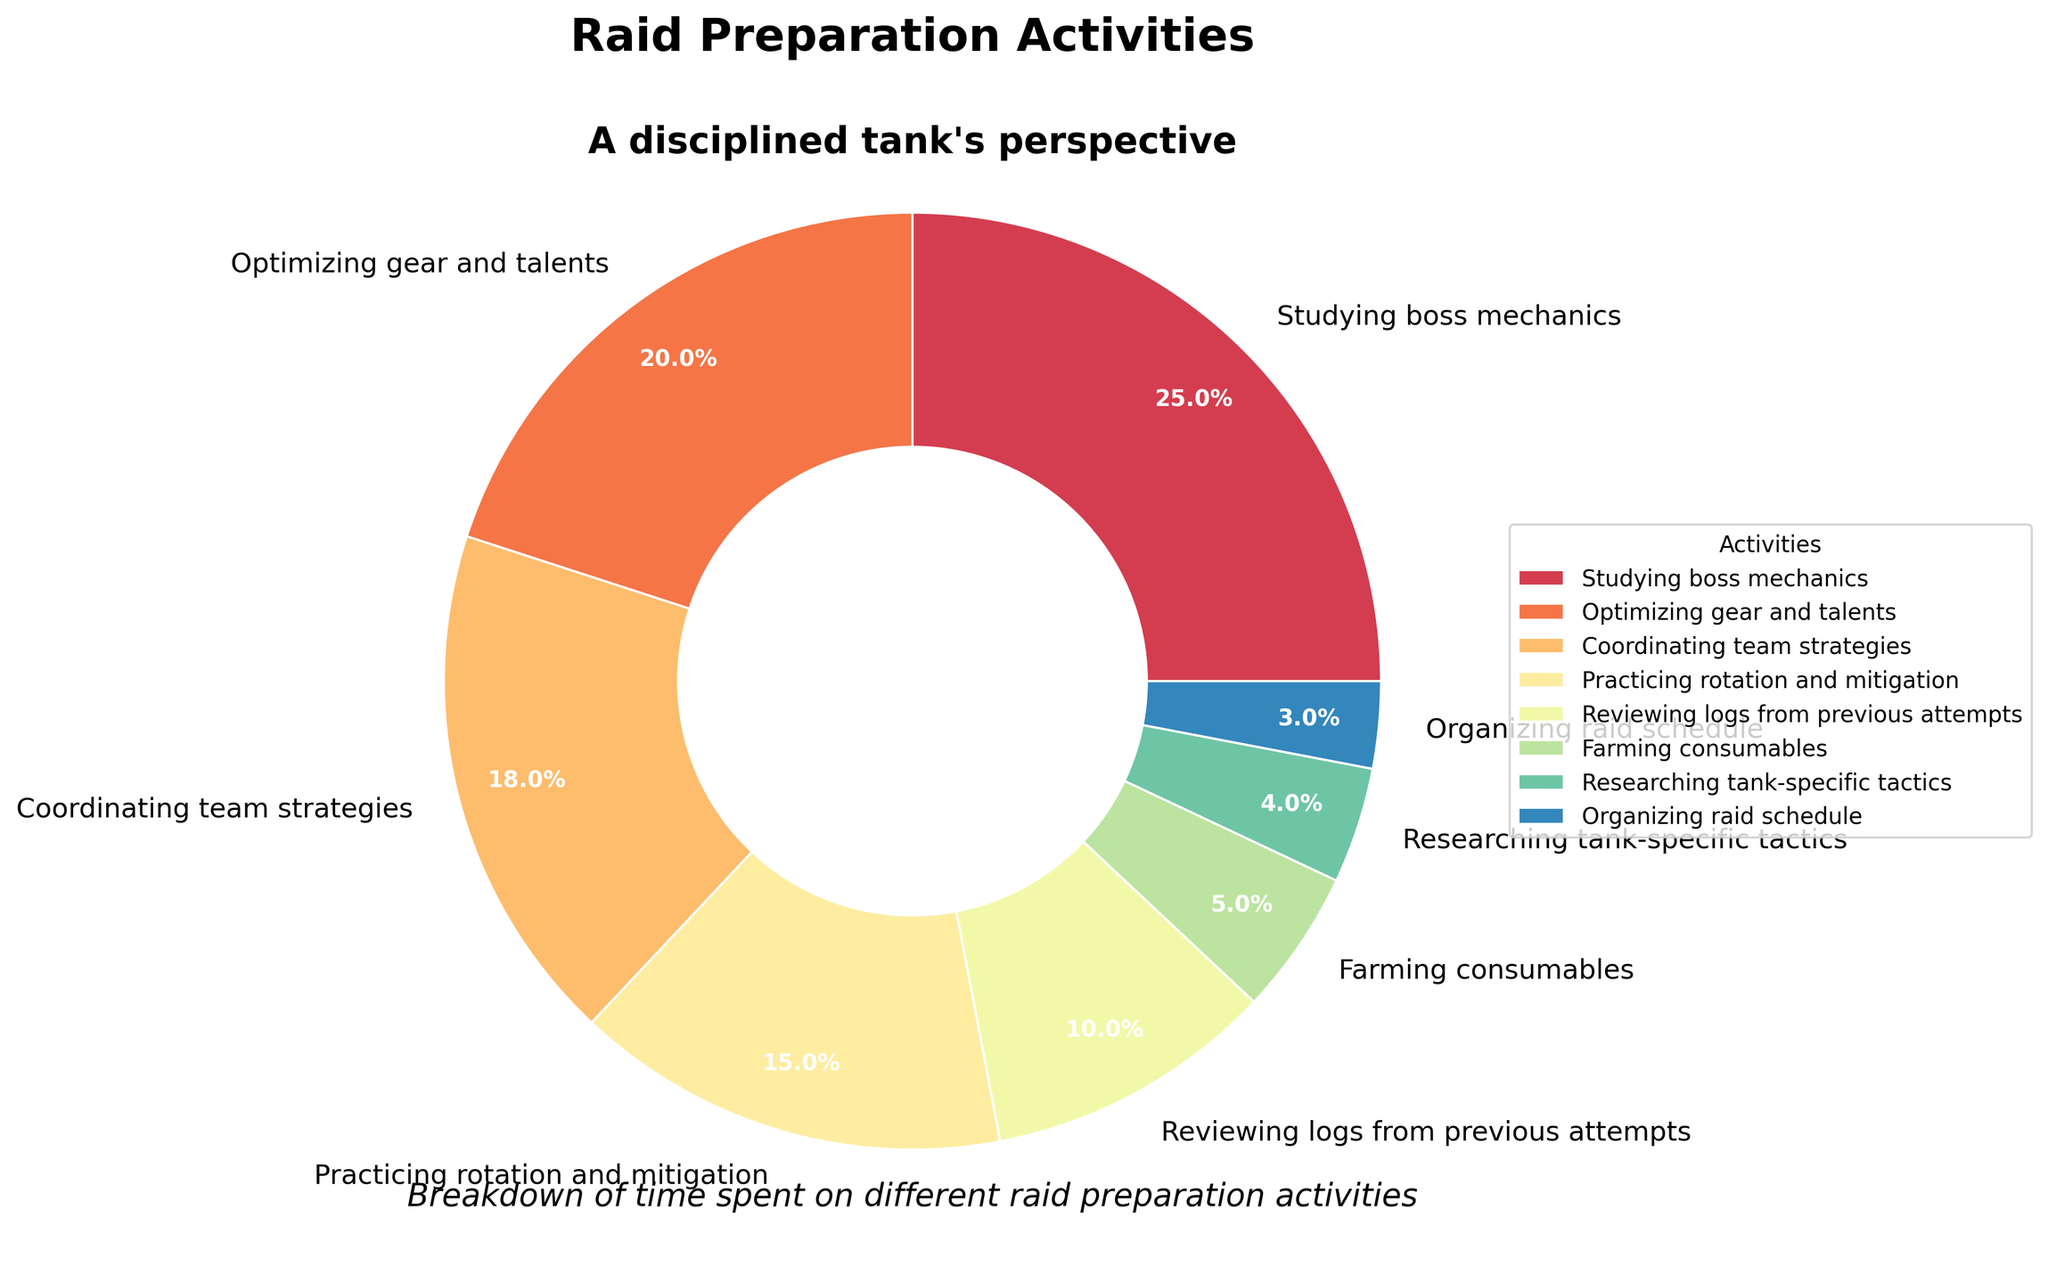What's the largest segment in the pie chart? The largest segment is the one that takes up the most space or the highest percentage. By observing the pie chart, the "Studying boss mechanics" segment is the largest.
Answer: Studying boss mechanics Which activity takes up the smallest portion of time? The smallest segment is the one covering the least space or representing the smallest percentage in the chart. Here, "Organizing raid schedule" is the smallest segment.
Answer: Organizing raid schedule How much time is spent on activities other than "Studying boss mechanics" and "Optimizing gear and talents"? To find the time spent on other activities, subtract the sum of percentages of "Studying boss mechanics" (25%) and "Optimizing gear and talents" (20%) from 100%. The calculation is 100 - (25 + 20) = 55%.
Answer: 55% Compare the time spent on "Coordinating team strategies" and "Practicing rotation and mitigation". Which one has a greater portion, and by how much? By looking at the percentages, "Coordinating team strategies" is 18% and "Practicing rotation and mitigation" is 15%. Therefore, "Coordinating team strategies" has a greater portion by 18% - 15% = 3%.
Answer: Coordinating team strategies; 3% What is the combined percentage of time spent on "Reviewing logs from previous attempts" and "Farming consumables"? To find the combined percentage, add the percentages of "Reviewing logs from previous attempts" (10%) and "Farming consumables" (5%). The sum is 10% + 5% = 15%.
Answer: 15% How many activities take up more than 10% of the total time? Count the segments in the pie chart that each have a percentage greater than 10%. Here, they are "Studying boss mechanics" (25%), "Optimizing gear and talents" (20%), "Coordinating team strategies" (18%), and "Practicing rotation and mitigation" (15%). There are 4 such activities.
Answer: 4 By how much does the time spent "Reviewing logs from previous attempts" exceed the time spent "Researching tank-specific tactics"? Subtract the percentage of "Researching tank-specific tactics" (4%) from "Reviewing logs from previous attempts" (10%). The difference is 10% - 4% = 6%.
Answer: 6% Arrange the activities in descending order of the time spent. Start from the highest percentage to the lowest. The order is:
1. Studying boss mechanics (25%)
2. Optimizing gear and talents (20%)
3. Coordinating team strategies (18%)
4. Practicing rotation and mitigation (15%)
5. Reviewing logs from previous attempts (10%)
6. Farming consumables (5%)
7. Researching tank-specific tactics (4%)
8. Organizing raid schedule (3%)
Answer: Listed order What percentage of time is collectively spent on the least three time-consuming activities? Sum the percentages of the least three time-consuming activities: "Farming consumables" (5%), "Researching tank-specific tactics" (4%), and "Organizing raid schedule" (3%). The total is 5% + 4% + 3% = 12%.
Answer: 12% 